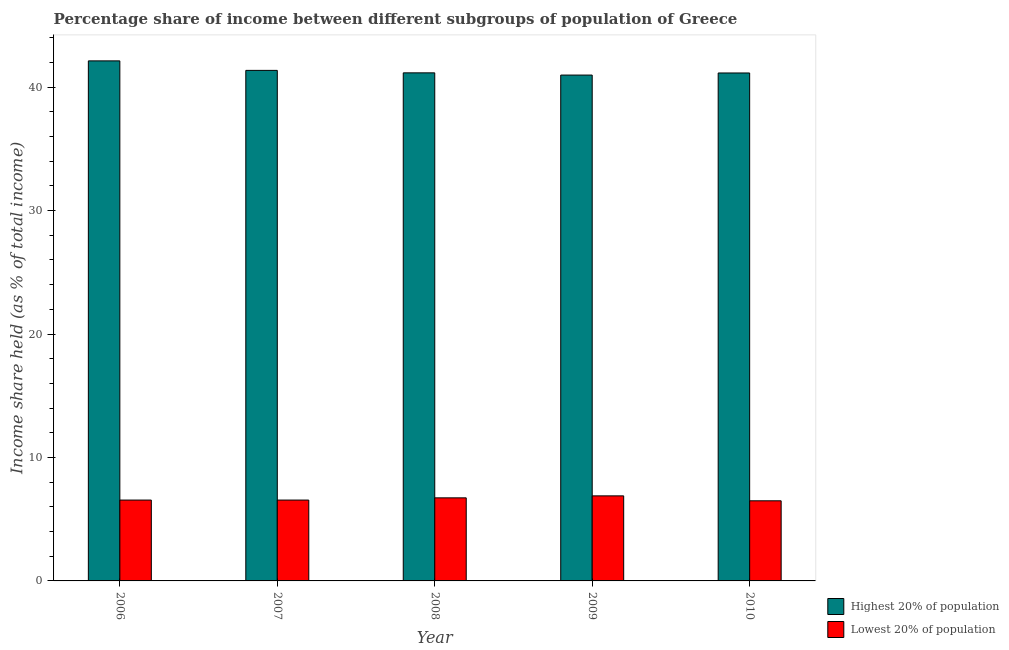Are the number of bars per tick equal to the number of legend labels?
Provide a succinct answer. Yes. In how many cases, is the number of bars for a given year not equal to the number of legend labels?
Make the answer very short. 0. What is the income share held by highest 20% of the population in 2008?
Your response must be concise. 41.16. Across all years, what is the maximum income share held by highest 20% of the population?
Your response must be concise. 42.13. Across all years, what is the minimum income share held by highest 20% of the population?
Ensure brevity in your answer.  40.98. What is the total income share held by highest 20% of the population in the graph?
Your answer should be very brief. 206.78. What is the difference between the income share held by lowest 20% of the population in 2006 and that in 2009?
Give a very brief answer. -0.34. What is the difference between the income share held by lowest 20% of the population in 2009 and the income share held by highest 20% of the population in 2006?
Give a very brief answer. 0.34. What is the average income share held by highest 20% of the population per year?
Provide a short and direct response. 41.36. In the year 2008, what is the difference between the income share held by lowest 20% of the population and income share held by highest 20% of the population?
Keep it short and to the point. 0. What is the ratio of the income share held by lowest 20% of the population in 2006 to that in 2008?
Your response must be concise. 0.97. What is the difference between the highest and the second highest income share held by highest 20% of the population?
Your answer should be compact. 0.77. What is the difference between the highest and the lowest income share held by highest 20% of the population?
Offer a very short reply. 1.15. What does the 2nd bar from the left in 2008 represents?
Make the answer very short. Lowest 20% of population. What does the 2nd bar from the right in 2007 represents?
Offer a terse response. Highest 20% of population. How many years are there in the graph?
Make the answer very short. 5. Does the graph contain any zero values?
Your response must be concise. No. Does the graph contain grids?
Provide a succinct answer. No. Where does the legend appear in the graph?
Provide a succinct answer. Bottom right. How many legend labels are there?
Ensure brevity in your answer.  2. How are the legend labels stacked?
Your answer should be compact. Vertical. What is the title of the graph?
Your answer should be very brief. Percentage share of income between different subgroups of population of Greece. What is the label or title of the Y-axis?
Your answer should be very brief. Income share held (as % of total income). What is the Income share held (as % of total income) in Highest 20% of population in 2006?
Ensure brevity in your answer.  42.13. What is the Income share held (as % of total income) of Lowest 20% of population in 2006?
Give a very brief answer. 6.55. What is the Income share held (as % of total income) of Highest 20% of population in 2007?
Your response must be concise. 41.36. What is the Income share held (as % of total income) in Lowest 20% of population in 2007?
Your response must be concise. 6.55. What is the Income share held (as % of total income) of Highest 20% of population in 2008?
Offer a very short reply. 41.16. What is the Income share held (as % of total income) of Lowest 20% of population in 2008?
Give a very brief answer. 6.73. What is the Income share held (as % of total income) in Highest 20% of population in 2009?
Make the answer very short. 40.98. What is the Income share held (as % of total income) of Lowest 20% of population in 2009?
Your answer should be compact. 6.89. What is the Income share held (as % of total income) in Highest 20% of population in 2010?
Keep it short and to the point. 41.15. What is the Income share held (as % of total income) in Lowest 20% of population in 2010?
Your answer should be very brief. 6.49. Across all years, what is the maximum Income share held (as % of total income) in Highest 20% of population?
Offer a very short reply. 42.13. Across all years, what is the maximum Income share held (as % of total income) in Lowest 20% of population?
Offer a terse response. 6.89. Across all years, what is the minimum Income share held (as % of total income) in Highest 20% of population?
Your response must be concise. 40.98. Across all years, what is the minimum Income share held (as % of total income) of Lowest 20% of population?
Ensure brevity in your answer.  6.49. What is the total Income share held (as % of total income) of Highest 20% of population in the graph?
Offer a very short reply. 206.78. What is the total Income share held (as % of total income) of Lowest 20% of population in the graph?
Offer a terse response. 33.21. What is the difference between the Income share held (as % of total income) of Highest 20% of population in 2006 and that in 2007?
Provide a short and direct response. 0.77. What is the difference between the Income share held (as % of total income) of Highest 20% of population in 2006 and that in 2008?
Your response must be concise. 0.97. What is the difference between the Income share held (as % of total income) of Lowest 20% of population in 2006 and that in 2008?
Ensure brevity in your answer.  -0.18. What is the difference between the Income share held (as % of total income) in Highest 20% of population in 2006 and that in 2009?
Your answer should be very brief. 1.15. What is the difference between the Income share held (as % of total income) in Lowest 20% of population in 2006 and that in 2009?
Give a very brief answer. -0.34. What is the difference between the Income share held (as % of total income) in Highest 20% of population in 2006 and that in 2010?
Your response must be concise. 0.98. What is the difference between the Income share held (as % of total income) of Lowest 20% of population in 2006 and that in 2010?
Your response must be concise. 0.06. What is the difference between the Income share held (as % of total income) in Highest 20% of population in 2007 and that in 2008?
Provide a short and direct response. 0.2. What is the difference between the Income share held (as % of total income) in Lowest 20% of population in 2007 and that in 2008?
Provide a short and direct response. -0.18. What is the difference between the Income share held (as % of total income) in Highest 20% of population in 2007 and that in 2009?
Keep it short and to the point. 0.38. What is the difference between the Income share held (as % of total income) in Lowest 20% of population in 2007 and that in 2009?
Provide a short and direct response. -0.34. What is the difference between the Income share held (as % of total income) of Highest 20% of population in 2007 and that in 2010?
Your response must be concise. 0.21. What is the difference between the Income share held (as % of total income) in Highest 20% of population in 2008 and that in 2009?
Keep it short and to the point. 0.18. What is the difference between the Income share held (as % of total income) in Lowest 20% of population in 2008 and that in 2009?
Your answer should be compact. -0.16. What is the difference between the Income share held (as % of total income) of Lowest 20% of population in 2008 and that in 2010?
Your answer should be very brief. 0.24. What is the difference between the Income share held (as % of total income) of Highest 20% of population in 2009 and that in 2010?
Your response must be concise. -0.17. What is the difference between the Income share held (as % of total income) in Lowest 20% of population in 2009 and that in 2010?
Give a very brief answer. 0.4. What is the difference between the Income share held (as % of total income) of Highest 20% of population in 2006 and the Income share held (as % of total income) of Lowest 20% of population in 2007?
Provide a short and direct response. 35.58. What is the difference between the Income share held (as % of total income) of Highest 20% of population in 2006 and the Income share held (as % of total income) of Lowest 20% of population in 2008?
Offer a very short reply. 35.4. What is the difference between the Income share held (as % of total income) in Highest 20% of population in 2006 and the Income share held (as % of total income) in Lowest 20% of population in 2009?
Your answer should be very brief. 35.24. What is the difference between the Income share held (as % of total income) in Highest 20% of population in 2006 and the Income share held (as % of total income) in Lowest 20% of population in 2010?
Provide a succinct answer. 35.64. What is the difference between the Income share held (as % of total income) in Highest 20% of population in 2007 and the Income share held (as % of total income) in Lowest 20% of population in 2008?
Offer a terse response. 34.63. What is the difference between the Income share held (as % of total income) of Highest 20% of population in 2007 and the Income share held (as % of total income) of Lowest 20% of population in 2009?
Make the answer very short. 34.47. What is the difference between the Income share held (as % of total income) of Highest 20% of population in 2007 and the Income share held (as % of total income) of Lowest 20% of population in 2010?
Give a very brief answer. 34.87. What is the difference between the Income share held (as % of total income) in Highest 20% of population in 2008 and the Income share held (as % of total income) in Lowest 20% of population in 2009?
Your answer should be very brief. 34.27. What is the difference between the Income share held (as % of total income) of Highest 20% of population in 2008 and the Income share held (as % of total income) of Lowest 20% of population in 2010?
Provide a succinct answer. 34.67. What is the difference between the Income share held (as % of total income) of Highest 20% of population in 2009 and the Income share held (as % of total income) of Lowest 20% of population in 2010?
Offer a terse response. 34.49. What is the average Income share held (as % of total income) in Highest 20% of population per year?
Your answer should be very brief. 41.36. What is the average Income share held (as % of total income) of Lowest 20% of population per year?
Offer a terse response. 6.64. In the year 2006, what is the difference between the Income share held (as % of total income) in Highest 20% of population and Income share held (as % of total income) in Lowest 20% of population?
Provide a succinct answer. 35.58. In the year 2007, what is the difference between the Income share held (as % of total income) in Highest 20% of population and Income share held (as % of total income) in Lowest 20% of population?
Make the answer very short. 34.81. In the year 2008, what is the difference between the Income share held (as % of total income) of Highest 20% of population and Income share held (as % of total income) of Lowest 20% of population?
Provide a short and direct response. 34.43. In the year 2009, what is the difference between the Income share held (as % of total income) in Highest 20% of population and Income share held (as % of total income) in Lowest 20% of population?
Ensure brevity in your answer.  34.09. In the year 2010, what is the difference between the Income share held (as % of total income) of Highest 20% of population and Income share held (as % of total income) of Lowest 20% of population?
Your response must be concise. 34.66. What is the ratio of the Income share held (as % of total income) of Highest 20% of population in 2006 to that in 2007?
Make the answer very short. 1.02. What is the ratio of the Income share held (as % of total income) in Lowest 20% of population in 2006 to that in 2007?
Ensure brevity in your answer.  1. What is the ratio of the Income share held (as % of total income) of Highest 20% of population in 2006 to that in 2008?
Provide a succinct answer. 1.02. What is the ratio of the Income share held (as % of total income) of Lowest 20% of population in 2006 to that in 2008?
Give a very brief answer. 0.97. What is the ratio of the Income share held (as % of total income) of Highest 20% of population in 2006 to that in 2009?
Keep it short and to the point. 1.03. What is the ratio of the Income share held (as % of total income) in Lowest 20% of population in 2006 to that in 2009?
Give a very brief answer. 0.95. What is the ratio of the Income share held (as % of total income) in Highest 20% of population in 2006 to that in 2010?
Keep it short and to the point. 1.02. What is the ratio of the Income share held (as % of total income) in Lowest 20% of population in 2006 to that in 2010?
Give a very brief answer. 1.01. What is the ratio of the Income share held (as % of total income) in Lowest 20% of population in 2007 to that in 2008?
Your answer should be very brief. 0.97. What is the ratio of the Income share held (as % of total income) of Highest 20% of population in 2007 to that in 2009?
Give a very brief answer. 1.01. What is the ratio of the Income share held (as % of total income) in Lowest 20% of population in 2007 to that in 2009?
Make the answer very short. 0.95. What is the ratio of the Income share held (as % of total income) in Lowest 20% of population in 2007 to that in 2010?
Your answer should be compact. 1.01. What is the ratio of the Income share held (as % of total income) of Lowest 20% of population in 2008 to that in 2009?
Keep it short and to the point. 0.98. What is the ratio of the Income share held (as % of total income) in Highest 20% of population in 2009 to that in 2010?
Your response must be concise. 1. What is the ratio of the Income share held (as % of total income) of Lowest 20% of population in 2009 to that in 2010?
Your answer should be very brief. 1.06. What is the difference between the highest and the second highest Income share held (as % of total income) in Highest 20% of population?
Provide a short and direct response. 0.77. What is the difference between the highest and the second highest Income share held (as % of total income) in Lowest 20% of population?
Ensure brevity in your answer.  0.16. What is the difference between the highest and the lowest Income share held (as % of total income) in Highest 20% of population?
Your response must be concise. 1.15. 